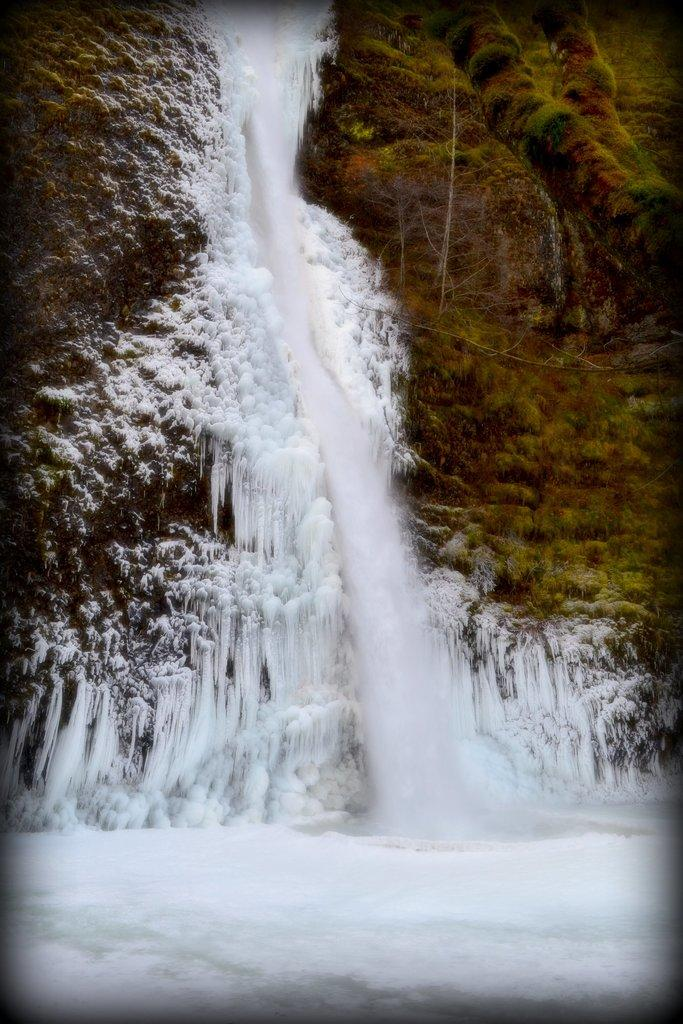What is the primary feature of the landscape in the image? There is snow in the image. What type of vegetation can be seen in the image? There is greenery in the right corner of the image. How many cushions are visible in the image? There are no cushions present in the image. What type of natural disaster is occurring in the image? There is no indication of a natural disaster, such as an earthquake, in the image. 